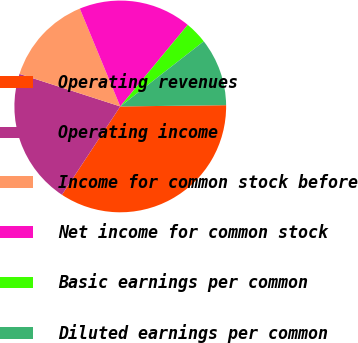Convert chart. <chart><loc_0><loc_0><loc_500><loc_500><pie_chart><fcel>Operating revenues<fcel>Operating income<fcel>Income for common stock before<fcel>Net income for common stock<fcel>Basic earnings per common<fcel>Diluted earnings per common<nl><fcel>34.47%<fcel>20.69%<fcel>13.79%<fcel>17.24%<fcel>3.46%<fcel>10.35%<nl></chart> 